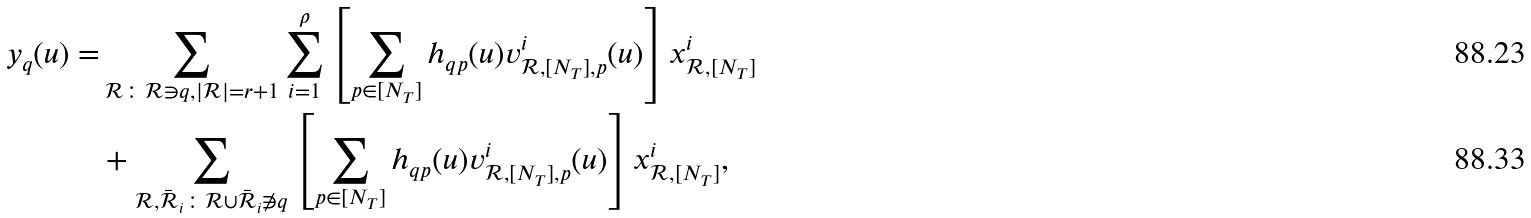<formula> <loc_0><loc_0><loc_500><loc_500>y _ { q } ( u ) = & \sum _ { \mathcal { R } \colon \mathcal { R } \ni q , | \mathcal { R } | = r + 1 } \sum _ { i = 1 } ^ { \rho } \left [ \sum _ { p \in [ N _ { T } ] } h _ { q p } ( u ) v _ { { \mathcal { R } } , { [ N _ { T } ] } , p } ^ { i } ( u ) \right ] x _ { { \mathcal { R } } , { [ N _ { T } ] } } ^ { i } \\ & + \sum _ { \mathcal { R } , \bar { \mathcal { R } } _ { i } \colon \mathcal { R } \cup \bar { \mathcal { R } } _ { i } \not \ni q } \left [ \sum _ { p \in [ N _ { T } ] } h _ { q p } ( u ) v _ { { \mathcal { R } } , { [ N _ { T } ] } , p } ^ { i } ( u ) \right ] x _ { { \mathcal { R } } , { [ N _ { T } ] } } ^ { i } ,</formula> 